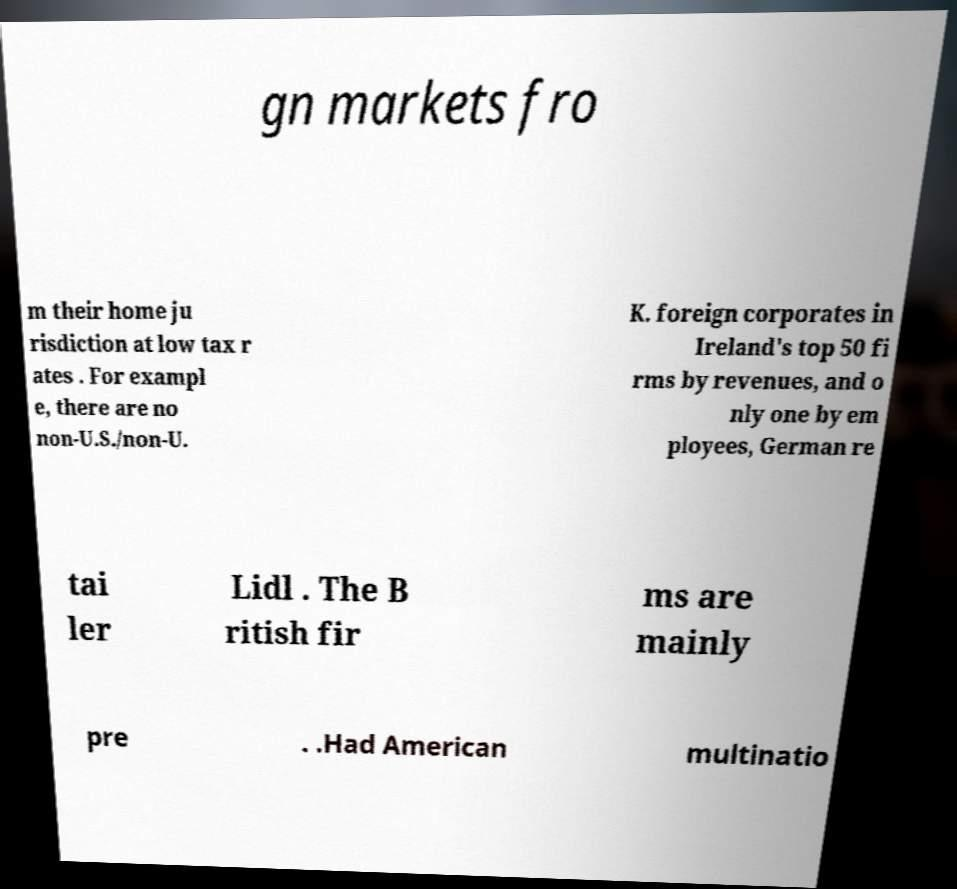Please read and relay the text visible in this image. What does it say? gn markets fro m their home ju risdiction at low tax r ates . For exampl e, there are no non-U.S./non-U. K. foreign corporates in Ireland's top 50 fi rms by revenues, and o nly one by em ployees, German re tai ler Lidl . The B ritish fir ms are mainly pre . .Had American multinatio 